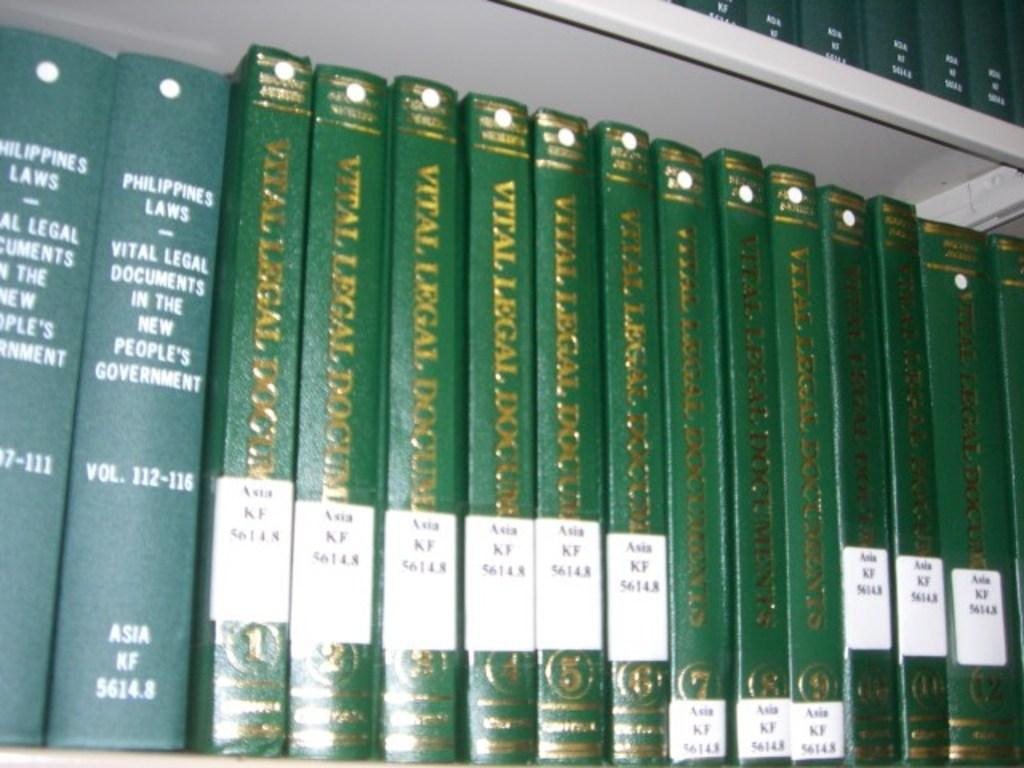<image>
Offer a succinct explanation of the picture presented. Vital legal documents books lined up on a bookshelf 